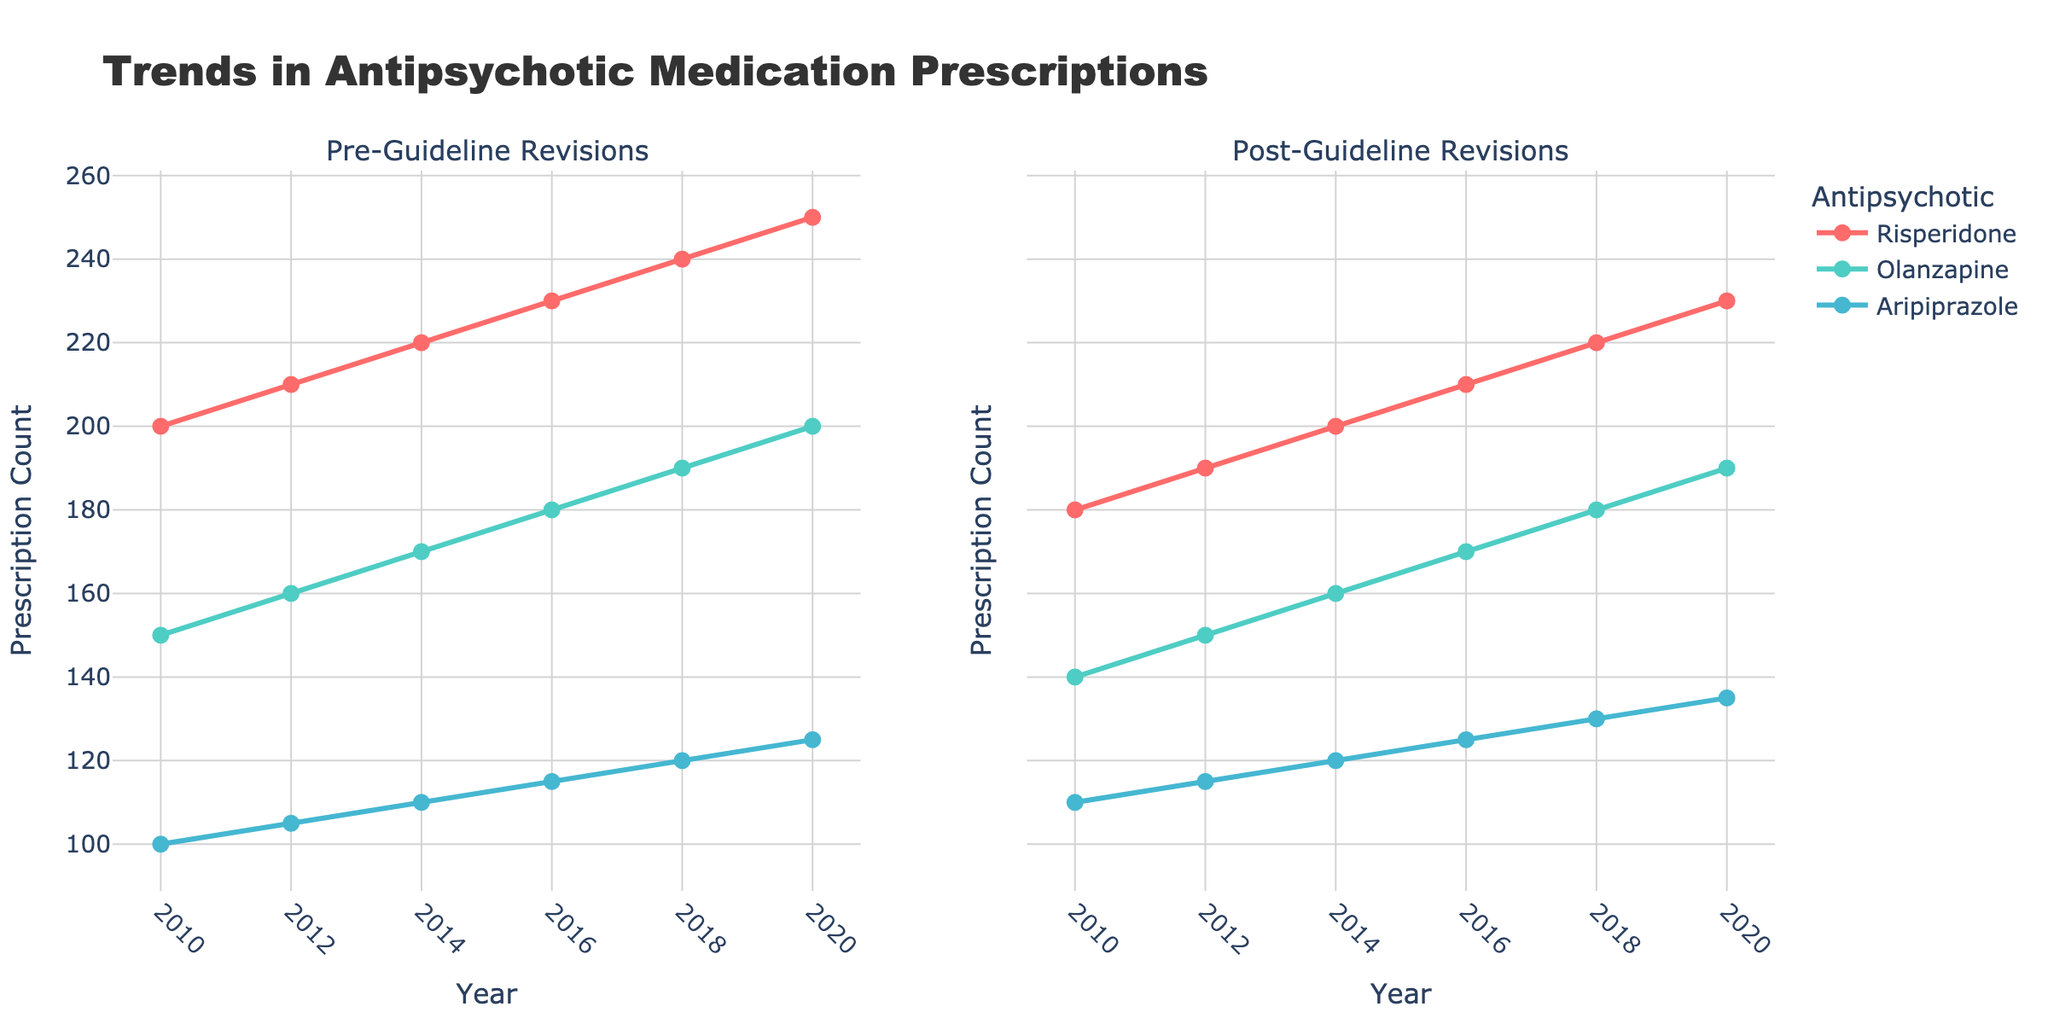What's the total number of prescription counts for Risperidone before guideline revisions in 2018? Look at the "Pre-Guideline Revisions" for Risperidone in 2018. According to the figure, it is 240.
Answer: 240 Which antipsychotic medication shows an increase in prescriptions after guideline revisions in 2010? Compare the "Pre-Guideline Revisions" and "Post-Guideline Revisions" counts for each antipsychotic in 2010. Aripiprazole shows an increase from 100 to 110.
Answer: Aripiprazole What’s the average number of pre-guideline prescriptions for Olanzapine across all years? Sum the pre-guideline prescription counts for Olanzapine (150 + 160 + 170 + 180 + 190 + 200) and divide by the number of years (6). The total is 1050, so the average is 1050 / 6 = 175.
Answer: 175 Between Risperidone and Olanzapine, which has a higher prescription count post-guideline revisions in 2020? Compare the post-guideline prescription counts for Risperidone and Olanzapine in 2020. Risperidone has 230, and Olanzapine has 190. Therefore, Risperidone is higher.
Answer: Risperidone Overall, does Aripiprazole show a consistent increase in prescriptions post-guideline revisions? Check the prescription counts of Aripiprazole post-guideline for each year (110, 115, 120, 125, 130, 135). The counts consistently increase over the years.
Answer: Yes What is the difference in prescription counts for Aripiprazole between 2020 and 2010 post-guideline revisions? Subtract the 2010 post-revision count from the 2020 post-revision count for Aripiprazole. The difference is 135 - 110 = 25.
Answer: 25 How do pre-guideline prescription trends for Aripiprazole compare to post-guideline trends from 2010 to 2020? Observe the line trends for Aripiprazole in both pre-guideline and post-guideline plots from 2010 to 2020. Pre-guideline trends are increasing steadily, and post-guideline trends also show a steady increase but at slightly higher counts.
Answer: Steady increase in both, slightly higher post-guideline Which antipsychotic had the highest prescription count in 2016 pre-guideline revisions? Check the pre-guideline prescription counts for all antipsychotics in 2016. Risperidone has the highest count at 230.
Answer: Risperidone Is there a notable drop in the prescription count for any antipsychotic immediately post-guideline revision? Compare pre- and post-guideline counts for each antipsychotic in consecutive years. Olanzapine shows a slight but consistent drop immediately post-guideline in various years.
Answer: Yes, Olanzapine 